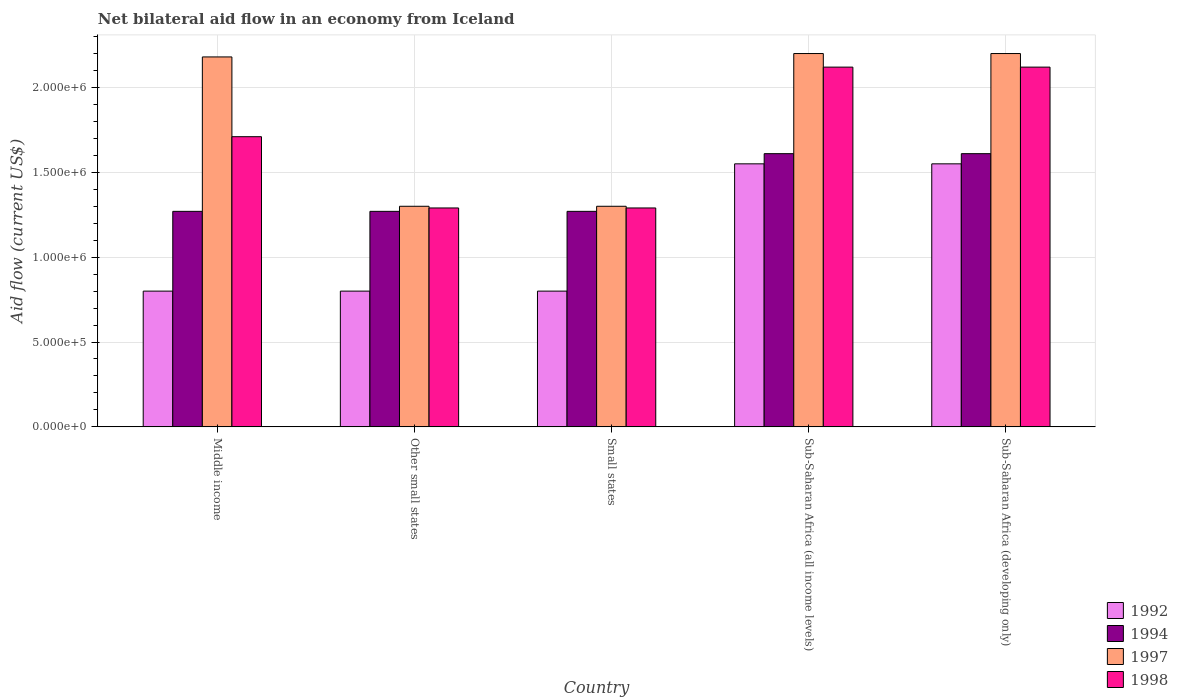How many groups of bars are there?
Your answer should be compact. 5. Are the number of bars on each tick of the X-axis equal?
Provide a short and direct response. Yes. How many bars are there on the 3rd tick from the right?
Provide a short and direct response. 4. What is the label of the 4th group of bars from the left?
Keep it short and to the point. Sub-Saharan Africa (all income levels). In how many cases, is the number of bars for a given country not equal to the number of legend labels?
Keep it short and to the point. 0. What is the net bilateral aid flow in 1998 in Sub-Saharan Africa (all income levels)?
Give a very brief answer. 2.12e+06. Across all countries, what is the maximum net bilateral aid flow in 1994?
Provide a succinct answer. 1.61e+06. Across all countries, what is the minimum net bilateral aid flow in 1992?
Your answer should be very brief. 8.00e+05. In which country was the net bilateral aid flow in 1994 maximum?
Give a very brief answer. Sub-Saharan Africa (all income levels). In which country was the net bilateral aid flow in 1998 minimum?
Offer a terse response. Other small states. What is the total net bilateral aid flow in 1998 in the graph?
Your answer should be very brief. 8.53e+06. What is the difference between the net bilateral aid flow in 1998 in Other small states and that in Sub-Saharan Africa (developing only)?
Keep it short and to the point. -8.30e+05. What is the difference between the net bilateral aid flow in 1997 in Middle income and the net bilateral aid flow in 1994 in Small states?
Offer a terse response. 9.10e+05. What is the average net bilateral aid flow in 1997 per country?
Your response must be concise. 1.84e+06. What is the difference between the net bilateral aid flow of/in 1992 and net bilateral aid flow of/in 1997 in Other small states?
Make the answer very short. -5.00e+05. What is the ratio of the net bilateral aid flow in 1992 in Middle income to that in Sub-Saharan Africa (all income levels)?
Keep it short and to the point. 0.52. Is the net bilateral aid flow in 1998 in Small states less than that in Sub-Saharan Africa (all income levels)?
Your response must be concise. Yes. Is the difference between the net bilateral aid flow in 1992 in Small states and Sub-Saharan Africa (all income levels) greater than the difference between the net bilateral aid flow in 1997 in Small states and Sub-Saharan Africa (all income levels)?
Offer a very short reply. Yes. What is the difference between the highest and the second highest net bilateral aid flow in 1998?
Give a very brief answer. 4.10e+05. In how many countries, is the net bilateral aid flow in 1992 greater than the average net bilateral aid flow in 1992 taken over all countries?
Keep it short and to the point. 2. Is it the case that in every country, the sum of the net bilateral aid flow in 1992 and net bilateral aid flow in 1998 is greater than the sum of net bilateral aid flow in 1994 and net bilateral aid flow in 1997?
Give a very brief answer. No. What does the 1st bar from the left in Sub-Saharan Africa (developing only) represents?
Offer a very short reply. 1992. What does the 4th bar from the right in Small states represents?
Make the answer very short. 1992. Is it the case that in every country, the sum of the net bilateral aid flow in 1992 and net bilateral aid flow in 1994 is greater than the net bilateral aid flow in 1997?
Provide a succinct answer. No. How many bars are there?
Make the answer very short. 20. Are the values on the major ticks of Y-axis written in scientific E-notation?
Ensure brevity in your answer.  Yes. Does the graph contain any zero values?
Make the answer very short. No. Does the graph contain grids?
Your answer should be compact. Yes. Where does the legend appear in the graph?
Keep it short and to the point. Bottom right. How many legend labels are there?
Make the answer very short. 4. How are the legend labels stacked?
Offer a terse response. Vertical. What is the title of the graph?
Offer a terse response. Net bilateral aid flow in an economy from Iceland. Does "1994" appear as one of the legend labels in the graph?
Ensure brevity in your answer.  Yes. What is the label or title of the Y-axis?
Provide a succinct answer. Aid flow (current US$). What is the Aid flow (current US$) of 1992 in Middle income?
Keep it short and to the point. 8.00e+05. What is the Aid flow (current US$) of 1994 in Middle income?
Provide a succinct answer. 1.27e+06. What is the Aid flow (current US$) of 1997 in Middle income?
Ensure brevity in your answer.  2.18e+06. What is the Aid flow (current US$) in 1998 in Middle income?
Offer a very short reply. 1.71e+06. What is the Aid flow (current US$) of 1992 in Other small states?
Keep it short and to the point. 8.00e+05. What is the Aid flow (current US$) of 1994 in Other small states?
Keep it short and to the point. 1.27e+06. What is the Aid flow (current US$) of 1997 in Other small states?
Your answer should be very brief. 1.30e+06. What is the Aid flow (current US$) in 1998 in Other small states?
Make the answer very short. 1.29e+06. What is the Aid flow (current US$) in 1994 in Small states?
Keep it short and to the point. 1.27e+06. What is the Aid flow (current US$) in 1997 in Small states?
Keep it short and to the point. 1.30e+06. What is the Aid flow (current US$) of 1998 in Small states?
Provide a succinct answer. 1.29e+06. What is the Aid flow (current US$) in 1992 in Sub-Saharan Africa (all income levels)?
Provide a short and direct response. 1.55e+06. What is the Aid flow (current US$) in 1994 in Sub-Saharan Africa (all income levels)?
Ensure brevity in your answer.  1.61e+06. What is the Aid flow (current US$) of 1997 in Sub-Saharan Africa (all income levels)?
Offer a very short reply. 2.20e+06. What is the Aid flow (current US$) of 1998 in Sub-Saharan Africa (all income levels)?
Keep it short and to the point. 2.12e+06. What is the Aid flow (current US$) in 1992 in Sub-Saharan Africa (developing only)?
Your answer should be very brief. 1.55e+06. What is the Aid flow (current US$) of 1994 in Sub-Saharan Africa (developing only)?
Keep it short and to the point. 1.61e+06. What is the Aid flow (current US$) in 1997 in Sub-Saharan Africa (developing only)?
Make the answer very short. 2.20e+06. What is the Aid flow (current US$) of 1998 in Sub-Saharan Africa (developing only)?
Your response must be concise. 2.12e+06. Across all countries, what is the maximum Aid flow (current US$) of 1992?
Your answer should be compact. 1.55e+06. Across all countries, what is the maximum Aid flow (current US$) of 1994?
Make the answer very short. 1.61e+06. Across all countries, what is the maximum Aid flow (current US$) of 1997?
Offer a terse response. 2.20e+06. Across all countries, what is the maximum Aid flow (current US$) of 1998?
Give a very brief answer. 2.12e+06. Across all countries, what is the minimum Aid flow (current US$) in 1992?
Offer a very short reply. 8.00e+05. Across all countries, what is the minimum Aid flow (current US$) of 1994?
Ensure brevity in your answer.  1.27e+06. Across all countries, what is the minimum Aid flow (current US$) in 1997?
Make the answer very short. 1.30e+06. Across all countries, what is the minimum Aid flow (current US$) in 1998?
Keep it short and to the point. 1.29e+06. What is the total Aid flow (current US$) of 1992 in the graph?
Offer a terse response. 5.50e+06. What is the total Aid flow (current US$) in 1994 in the graph?
Make the answer very short. 7.03e+06. What is the total Aid flow (current US$) in 1997 in the graph?
Offer a terse response. 9.18e+06. What is the total Aid flow (current US$) in 1998 in the graph?
Keep it short and to the point. 8.53e+06. What is the difference between the Aid flow (current US$) in 1992 in Middle income and that in Other small states?
Keep it short and to the point. 0. What is the difference between the Aid flow (current US$) of 1997 in Middle income and that in Other small states?
Offer a terse response. 8.80e+05. What is the difference between the Aid flow (current US$) in 1998 in Middle income and that in Other small states?
Give a very brief answer. 4.20e+05. What is the difference between the Aid flow (current US$) in 1997 in Middle income and that in Small states?
Offer a terse response. 8.80e+05. What is the difference between the Aid flow (current US$) in 1992 in Middle income and that in Sub-Saharan Africa (all income levels)?
Offer a terse response. -7.50e+05. What is the difference between the Aid flow (current US$) in 1994 in Middle income and that in Sub-Saharan Africa (all income levels)?
Offer a terse response. -3.40e+05. What is the difference between the Aid flow (current US$) in 1998 in Middle income and that in Sub-Saharan Africa (all income levels)?
Your answer should be very brief. -4.10e+05. What is the difference between the Aid flow (current US$) of 1992 in Middle income and that in Sub-Saharan Africa (developing only)?
Offer a very short reply. -7.50e+05. What is the difference between the Aid flow (current US$) in 1994 in Middle income and that in Sub-Saharan Africa (developing only)?
Make the answer very short. -3.40e+05. What is the difference between the Aid flow (current US$) of 1998 in Middle income and that in Sub-Saharan Africa (developing only)?
Keep it short and to the point. -4.10e+05. What is the difference between the Aid flow (current US$) of 1992 in Other small states and that in Small states?
Your answer should be very brief. 0. What is the difference between the Aid flow (current US$) in 1994 in Other small states and that in Small states?
Offer a very short reply. 0. What is the difference between the Aid flow (current US$) of 1997 in Other small states and that in Small states?
Give a very brief answer. 0. What is the difference between the Aid flow (current US$) of 1992 in Other small states and that in Sub-Saharan Africa (all income levels)?
Provide a succinct answer. -7.50e+05. What is the difference between the Aid flow (current US$) in 1994 in Other small states and that in Sub-Saharan Africa (all income levels)?
Your answer should be very brief. -3.40e+05. What is the difference between the Aid flow (current US$) of 1997 in Other small states and that in Sub-Saharan Africa (all income levels)?
Give a very brief answer. -9.00e+05. What is the difference between the Aid flow (current US$) in 1998 in Other small states and that in Sub-Saharan Africa (all income levels)?
Provide a succinct answer. -8.30e+05. What is the difference between the Aid flow (current US$) of 1992 in Other small states and that in Sub-Saharan Africa (developing only)?
Your answer should be compact. -7.50e+05. What is the difference between the Aid flow (current US$) in 1994 in Other small states and that in Sub-Saharan Africa (developing only)?
Provide a short and direct response. -3.40e+05. What is the difference between the Aid flow (current US$) of 1997 in Other small states and that in Sub-Saharan Africa (developing only)?
Make the answer very short. -9.00e+05. What is the difference between the Aid flow (current US$) in 1998 in Other small states and that in Sub-Saharan Africa (developing only)?
Ensure brevity in your answer.  -8.30e+05. What is the difference between the Aid flow (current US$) of 1992 in Small states and that in Sub-Saharan Africa (all income levels)?
Provide a succinct answer. -7.50e+05. What is the difference between the Aid flow (current US$) in 1997 in Small states and that in Sub-Saharan Africa (all income levels)?
Offer a very short reply. -9.00e+05. What is the difference between the Aid flow (current US$) of 1998 in Small states and that in Sub-Saharan Africa (all income levels)?
Your response must be concise. -8.30e+05. What is the difference between the Aid flow (current US$) of 1992 in Small states and that in Sub-Saharan Africa (developing only)?
Ensure brevity in your answer.  -7.50e+05. What is the difference between the Aid flow (current US$) of 1994 in Small states and that in Sub-Saharan Africa (developing only)?
Ensure brevity in your answer.  -3.40e+05. What is the difference between the Aid flow (current US$) in 1997 in Small states and that in Sub-Saharan Africa (developing only)?
Keep it short and to the point. -9.00e+05. What is the difference between the Aid flow (current US$) of 1998 in Small states and that in Sub-Saharan Africa (developing only)?
Your response must be concise. -8.30e+05. What is the difference between the Aid flow (current US$) of 1992 in Sub-Saharan Africa (all income levels) and that in Sub-Saharan Africa (developing only)?
Your answer should be compact. 0. What is the difference between the Aid flow (current US$) in 1997 in Sub-Saharan Africa (all income levels) and that in Sub-Saharan Africa (developing only)?
Provide a succinct answer. 0. What is the difference between the Aid flow (current US$) in 1992 in Middle income and the Aid flow (current US$) in 1994 in Other small states?
Your response must be concise. -4.70e+05. What is the difference between the Aid flow (current US$) in 1992 in Middle income and the Aid flow (current US$) in 1997 in Other small states?
Give a very brief answer. -5.00e+05. What is the difference between the Aid flow (current US$) of 1992 in Middle income and the Aid flow (current US$) of 1998 in Other small states?
Make the answer very short. -4.90e+05. What is the difference between the Aid flow (current US$) of 1997 in Middle income and the Aid flow (current US$) of 1998 in Other small states?
Your answer should be compact. 8.90e+05. What is the difference between the Aid flow (current US$) in 1992 in Middle income and the Aid flow (current US$) in 1994 in Small states?
Keep it short and to the point. -4.70e+05. What is the difference between the Aid flow (current US$) of 1992 in Middle income and the Aid flow (current US$) of 1997 in Small states?
Offer a very short reply. -5.00e+05. What is the difference between the Aid flow (current US$) of 1992 in Middle income and the Aid flow (current US$) of 1998 in Small states?
Give a very brief answer. -4.90e+05. What is the difference between the Aid flow (current US$) of 1994 in Middle income and the Aid flow (current US$) of 1997 in Small states?
Your answer should be compact. -3.00e+04. What is the difference between the Aid flow (current US$) in 1994 in Middle income and the Aid flow (current US$) in 1998 in Small states?
Provide a short and direct response. -2.00e+04. What is the difference between the Aid flow (current US$) of 1997 in Middle income and the Aid flow (current US$) of 1998 in Small states?
Offer a very short reply. 8.90e+05. What is the difference between the Aid flow (current US$) of 1992 in Middle income and the Aid flow (current US$) of 1994 in Sub-Saharan Africa (all income levels)?
Keep it short and to the point. -8.10e+05. What is the difference between the Aid flow (current US$) in 1992 in Middle income and the Aid flow (current US$) in 1997 in Sub-Saharan Africa (all income levels)?
Provide a short and direct response. -1.40e+06. What is the difference between the Aid flow (current US$) in 1992 in Middle income and the Aid flow (current US$) in 1998 in Sub-Saharan Africa (all income levels)?
Make the answer very short. -1.32e+06. What is the difference between the Aid flow (current US$) in 1994 in Middle income and the Aid flow (current US$) in 1997 in Sub-Saharan Africa (all income levels)?
Offer a very short reply. -9.30e+05. What is the difference between the Aid flow (current US$) in 1994 in Middle income and the Aid flow (current US$) in 1998 in Sub-Saharan Africa (all income levels)?
Provide a short and direct response. -8.50e+05. What is the difference between the Aid flow (current US$) in 1997 in Middle income and the Aid flow (current US$) in 1998 in Sub-Saharan Africa (all income levels)?
Your response must be concise. 6.00e+04. What is the difference between the Aid flow (current US$) of 1992 in Middle income and the Aid flow (current US$) of 1994 in Sub-Saharan Africa (developing only)?
Make the answer very short. -8.10e+05. What is the difference between the Aid flow (current US$) of 1992 in Middle income and the Aid flow (current US$) of 1997 in Sub-Saharan Africa (developing only)?
Provide a succinct answer. -1.40e+06. What is the difference between the Aid flow (current US$) in 1992 in Middle income and the Aid flow (current US$) in 1998 in Sub-Saharan Africa (developing only)?
Your answer should be compact. -1.32e+06. What is the difference between the Aid flow (current US$) in 1994 in Middle income and the Aid flow (current US$) in 1997 in Sub-Saharan Africa (developing only)?
Make the answer very short. -9.30e+05. What is the difference between the Aid flow (current US$) in 1994 in Middle income and the Aid flow (current US$) in 1998 in Sub-Saharan Africa (developing only)?
Ensure brevity in your answer.  -8.50e+05. What is the difference between the Aid flow (current US$) of 1992 in Other small states and the Aid flow (current US$) of 1994 in Small states?
Your answer should be very brief. -4.70e+05. What is the difference between the Aid flow (current US$) in 1992 in Other small states and the Aid flow (current US$) in 1997 in Small states?
Your response must be concise. -5.00e+05. What is the difference between the Aid flow (current US$) of 1992 in Other small states and the Aid flow (current US$) of 1998 in Small states?
Make the answer very short. -4.90e+05. What is the difference between the Aid flow (current US$) in 1994 in Other small states and the Aid flow (current US$) in 1997 in Small states?
Your answer should be compact. -3.00e+04. What is the difference between the Aid flow (current US$) in 1994 in Other small states and the Aid flow (current US$) in 1998 in Small states?
Provide a succinct answer. -2.00e+04. What is the difference between the Aid flow (current US$) of 1997 in Other small states and the Aid flow (current US$) of 1998 in Small states?
Your answer should be very brief. 10000. What is the difference between the Aid flow (current US$) in 1992 in Other small states and the Aid flow (current US$) in 1994 in Sub-Saharan Africa (all income levels)?
Your answer should be very brief. -8.10e+05. What is the difference between the Aid flow (current US$) in 1992 in Other small states and the Aid flow (current US$) in 1997 in Sub-Saharan Africa (all income levels)?
Make the answer very short. -1.40e+06. What is the difference between the Aid flow (current US$) in 1992 in Other small states and the Aid flow (current US$) in 1998 in Sub-Saharan Africa (all income levels)?
Provide a succinct answer. -1.32e+06. What is the difference between the Aid flow (current US$) in 1994 in Other small states and the Aid flow (current US$) in 1997 in Sub-Saharan Africa (all income levels)?
Your answer should be very brief. -9.30e+05. What is the difference between the Aid flow (current US$) of 1994 in Other small states and the Aid flow (current US$) of 1998 in Sub-Saharan Africa (all income levels)?
Provide a short and direct response. -8.50e+05. What is the difference between the Aid flow (current US$) in 1997 in Other small states and the Aid flow (current US$) in 1998 in Sub-Saharan Africa (all income levels)?
Provide a short and direct response. -8.20e+05. What is the difference between the Aid flow (current US$) in 1992 in Other small states and the Aid flow (current US$) in 1994 in Sub-Saharan Africa (developing only)?
Provide a succinct answer. -8.10e+05. What is the difference between the Aid flow (current US$) in 1992 in Other small states and the Aid flow (current US$) in 1997 in Sub-Saharan Africa (developing only)?
Your answer should be compact. -1.40e+06. What is the difference between the Aid flow (current US$) in 1992 in Other small states and the Aid flow (current US$) in 1998 in Sub-Saharan Africa (developing only)?
Make the answer very short. -1.32e+06. What is the difference between the Aid flow (current US$) in 1994 in Other small states and the Aid flow (current US$) in 1997 in Sub-Saharan Africa (developing only)?
Ensure brevity in your answer.  -9.30e+05. What is the difference between the Aid flow (current US$) of 1994 in Other small states and the Aid flow (current US$) of 1998 in Sub-Saharan Africa (developing only)?
Offer a very short reply. -8.50e+05. What is the difference between the Aid flow (current US$) of 1997 in Other small states and the Aid flow (current US$) of 1998 in Sub-Saharan Africa (developing only)?
Your answer should be very brief. -8.20e+05. What is the difference between the Aid flow (current US$) in 1992 in Small states and the Aid flow (current US$) in 1994 in Sub-Saharan Africa (all income levels)?
Make the answer very short. -8.10e+05. What is the difference between the Aid flow (current US$) of 1992 in Small states and the Aid flow (current US$) of 1997 in Sub-Saharan Africa (all income levels)?
Offer a very short reply. -1.40e+06. What is the difference between the Aid flow (current US$) of 1992 in Small states and the Aid flow (current US$) of 1998 in Sub-Saharan Africa (all income levels)?
Your answer should be very brief. -1.32e+06. What is the difference between the Aid flow (current US$) in 1994 in Small states and the Aid flow (current US$) in 1997 in Sub-Saharan Africa (all income levels)?
Provide a succinct answer. -9.30e+05. What is the difference between the Aid flow (current US$) in 1994 in Small states and the Aid flow (current US$) in 1998 in Sub-Saharan Africa (all income levels)?
Your answer should be very brief. -8.50e+05. What is the difference between the Aid flow (current US$) of 1997 in Small states and the Aid flow (current US$) of 1998 in Sub-Saharan Africa (all income levels)?
Make the answer very short. -8.20e+05. What is the difference between the Aid flow (current US$) of 1992 in Small states and the Aid flow (current US$) of 1994 in Sub-Saharan Africa (developing only)?
Make the answer very short. -8.10e+05. What is the difference between the Aid flow (current US$) of 1992 in Small states and the Aid flow (current US$) of 1997 in Sub-Saharan Africa (developing only)?
Give a very brief answer. -1.40e+06. What is the difference between the Aid flow (current US$) of 1992 in Small states and the Aid flow (current US$) of 1998 in Sub-Saharan Africa (developing only)?
Make the answer very short. -1.32e+06. What is the difference between the Aid flow (current US$) in 1994 in Small states and the Aid flow (current US$) in 1997 in Sub-Saharan Africa (developing only)?
Make the answer very short. -9.30e+05. What is the difference between the Aid flow (current US$) of 1994 in Small states and the Aid flow (current US$) of 1998 in Sub-Saharan Africa (developing only)?
Ensure brevity in your answer.  -8.50e+05. What is the difference between the Aid flow (current US$) of 1997 in Small states and the Aid flow (current US$) of 1998 in Sub-Saharan Africa (developing only)?
Provide a short and direct response. -8.20e+05. What is the difference between the Aid flow (current US$) in 1992 in Sub-Saharan Africa (all income levels) and the Aid flow (current US$) in 1994 in Sub-Saharan Africa (developing only)?
Your answer should be very brief. -6.00e+04. What is the difference between the Aid flow (current US$) in 1992 in Sub-Saharan Africa (all income levels) and the Aid flow (current US$) in 1997 in Sub-Saharan Africa (developing only)?
Give a very brief answer. -6.50e+05. What is the difference between the Aid flow (current US$) of 1992 in Sub-Saharan Africa (all income levels) and the Aid flow (current US$) of 1998 in Sub-Saharan Africa (developing only)?
Provide a succinct answer. -5.70e+05. What is the difference between the Aid flow (current US$) in 1994 in Sub-Saharan Africa (all income levels) and the Aid flow (current US$) in 1997 in Sub-Saharan Africa (developing only)?
Provide a succinct answer. -5.90e+05. What is the difference between the Aid flow (current US$) in 1994 in Sub-Saharan Africa (all income levels) and the Aid flow (current US$) in 1998 in Sub-Saharan Africa (developing only)?
Your answer should be very brief. -5.10e+05. What is the difference between the Aid flow (current US$) in 1997 in Sub-Saharan Africa (all income levels) and the Aid flow (current US$) in 1998 in Sub-Saharan Africa (developing only)?
Your response must be concise. 8.00e+04. What is the average Aid flow (current US$) in 1992 per country?
Your answer should be compact. 1.10e+06. What is the average Aid flow (current US$) in 1994 per country?
Your response must be concise. 1.41e+06. What is the average Aid flow (current US$) in 1997 per country?
Provide a succinct answer. 1.84e+06. What is the average Aid flow (current US$) in 1998 per country?
Provide a short and direct response. 1.71e+06. What is the difference between the Aid flow (current US$) of 1992 and Aid flow (current US$) of 1994 in Middle income?
Give a very brief answer. -4.70e+05. What is the difference between the Aid flow (current US$) of 1992 and Aid flow (current US$) of 1997 in Middle income?
Ensure brevity in your answer.  -1.38e+06. What is the difference between the Aid flow (current US$) of 1992 and Aid flow (current US$) of 1998 in Middle income?
Offer a very short reply. -9.10e+05. What is the difference between the Aid flow (current US$) in 1994 and Aid flow (current US$) in 1997 in Middle income?
Make the answer very short. -9.10e+05. What is the difference between the Aid flow (current US$) of 1994 and Aid flow (current US$) of 1998 in Middle income?
Your answer should be very brief. -4.40e+05. What is the difference between the Aid flow (current US$) in 1992 and Aid flow (current US$) in 1994 in Other small states?
Ensure brevity in your answer.  -4.70e+05. What is the difference between the Aid flow (current US$) of 1992 and Aid flow (current US$) of 1997 in Other small states?
Your response must be concise. -5.00e+05. What is the difference between the Aid flow (current US$) in 1992 and Aid flow (current US$) in 1998 in Other small states?
Your answer should be very brief. -4.90e+05. What is the difference between the Aid flow (current US$) of 1994 and Aid flow (current US$) of 1998 in Other small states?
Offer a very short reply. -2.00e+04. What is the difference between the Aid flow (current US$) in 1992 and Aid flow (current US$) in 1994 in Small states?
Offer a very short reply. -4.70e+05. What is the difference between the Aid flow (current US$) of 1992 and Aid flow (current US$) of 1997 in Small states?
Provide a succinct answer. -5.00e+05. What is the difference between the Aid flow (current US$) of 1992 and Aid flow (current US$) of 1998 in Small states?
Your response must be concise. -4.90e+05. What is the difference between the Aid flow (current US$) in 1994 and Aid flow (current US$) in 1997 in Small states?
Provide a succinct answer. -3.00e+04. What is the difference between the Aid flow (current US$) of 1994 and Aid flow (current US$) of 1998 in Small states?
Your response must be concise. -2.00e+04. What is the difference between the Aid flow (current US$) in 1997 and Aid flow (current US$) in 1998 in Small states?
Provide a short and direct response. 10000. What is the difference between the Aid flow (current US$) of 1992 and Aid flow (current US$) of 1994 in Sub-Saharan Africa (all income levels)?
Make the answer very short. -6.00e+04. What is the difference between the Aid flow (current US$) in 1992 and Aid flow (current US$) in 1997 in Sub-Saharan Africa (all income levels)?
Provide a succinct answer. -6.50e+05. What is the difference between the Aid flow (current US$) of 1992 and Aid flow (current US$) of 1998 in Sub-Saharan Africa (all income levels)?
Ensure brevity in your answer.  -5.70e+05. What is the difference between the Aid flow (current US$) in 1994 and Aid flow (current US$) in 1997 in Sub-Saharan Africa (all income levels)?
Ensure brevity in your answer.  -5.90e+05. What is the difference between the Aid flow (current US$) in 1994 and Aid flow (current US$) in 1998 in Sub-Saharan Africa (all income levels)?
Ensure brevity in your answer.  -5.10e+05. What is the difference between the Aid flow (current US$) in 1992 and Aid flow (current US$) in 1994 in Sub-Saharan Africa (developing only)?
Provide a short and direct response. -6.00e+04. What is the difference between the Aid flow (current US$) of 1992 and Aid flow (current US$) of 1997 in Sub-Saharan Africa (developing only)?
Provide a short and direct response. -6.50e+05. What is the difference between the Aid flow (current US$) in 1992 and Aid flow (current US$) in 1998 in Sub-Saharan Africa (developing only)?
Provide a short and direct response. -5.70e+05. What is the difference between the Aid flow (current US$) of 1994 and Aid flow (current US$) of 1997 in Sub-Saharan Africa (developing only)?
Provide a succinct answer. -5.90e+05. What is the difference between the Aid flow (current US$) in 1994 and Aid flow (current US$) in 1998 in Sub-Saharan Africa (developing only)?
Your response must be concise. -5.10e+05. What is the ratio of the Aid flow (current US$) of 1994 in Middle income to that in Other small states?
Offer a terse response. 1. What is the ratio of the Aid flow (current US$) in 1997 in Middle income to that in Other small states?
Keep it short and to the point. 1.68. What is the ratio of the Aid flow (current US$) of 1998 in Middle income to that in Other small states?
Give a very brief answer. 1.33. What is the ratio of the Aid flow (current US$) in 1997 in Middle income to that in Small states?
Keep it short and to the point. 1.68. What is the ratio of the Aid flow (current US$) of 1998 in Middle income to that in Small states?
Keep it short and to the point. 1.33. What is the ratio of the Aid flow (current US$) of 1992 in Middle income to that in Sub-Saharan Africa (all income levels)?
Make the answer very short. 0.52. What is the ratio of the Aid flow (current US$) of 1994 in Middle income to that in Sub-Saharan Africa (all income levels)?
Your answer should be very brief. 0.79. What is the ratio of the Aid flow (current US$) of 1997 in Middle income to that in Sub-Saharan Africa (all income levels)?
Make the answer very short. 0.99. What is the ratio of the Aid flow (current US$) in 1998 in Middle income to that in Sub-Saharan Africa (all income levels)?
Keep it short and to the point. 0.81. What is the ratio of the Aid flow (current US$) in 1992 in Middle income to that in Sub-Saharan Africa (developing only)?
Your answer should be very brief. 0.52. What is the ratio of the Aid flow (current US$) of 1994 in Middle income to that in Sub-Saharan Africa (developing only)?
Keep it short and to the point. 0.79. What is the ratio of the Aid flow (current US$) in 1997 in Middle income to that in Sub-Saharan Africa (developing only)?
Keep it short and to the point. 0.99. What is the ratio of the Aid flow (current US$) of 1998 in Middle income to that in Sub-Saharan Africa (developing only)?
Your response must be concise. 0.81. What is the ratio of the Aid flow (current US$) of 1994 in Other small states to that in Small states?
Ensure brevity in your answer.  1. What is the ratio of the Aid flow (current US$) in 1997 in Other small states to that in Small states?
Your answer should be compact. 1. What is the ratio of the Aid flow (current US$) in 1998 in Other small states to that in Small states?
Offer a terse response. 1. What is the ratio of the Aid flow (current US$) in 1992 in Other small states to that in Sub-Saharan Africa (all income levels)?
Give a very brief answer. 0.52. What is the ratio of the Aid flow (current US$) in 1994 in Other small states to that in Sub-Saharan Africa (all income levels)?
Offer a very short reply. 0.79. What is the ratio of the Aid flow (current US$) of 1997 in Other small states to that in Sub-Saharan Africa (all income levels)?
Ensure brevity in your answer.  0.59. What is the ratio of the Aid flow (current US$) in 1998 in Other small states to that in Sub-Saharan Africa (all income levels)?
Your answer should be compact. 0.61. What is the ratio of the Aid flow (current US$) of 1992 in Other small states to that in Sub-Saharan Africa (developing only)?
Ensure brevity in your answer.  0.52. What is the ratio of the Aid flow (current US$) in 1994 in Other small states to that in Sub-Saharan Africa (developing only)?
Keep it short and to the point. 0.79. What is the ratio of the Aid flow (current US$) in 1997 in Other small states to that in Sub-Saharan Africa (developing only)?
Keep it short and to the point. 0.59. What is the ratio of the Aid flow (current US$) of 1998 in Other small states to that in Sub-Saharan Africa (developing only)?
Provide a succinct answer. 0.61. What is the ratio of the Aid flow (current US$) of 1992 in Small states to that in Sub-Saharan Africa (all income levels)?
Offer a terse response. 0.52. What is the ratio of the Aid flow (current US$) of 1994 in Small states to that in Sub-Saharan Africa (all income levels)?
Provide a succinct answer. 0.79. What is the ratio of the Aid flow (current US$) in 1997 in Small states to that in Sub-Saharan Africa (all income levels)?
Keep it short and to the point. 0.59. What is the ratio of the Aid flow (current US$) of 1998 in Small states to that in Sub-Saharan Africa (all income levels)?
Make the answer very short. 0.61. What is the ratio of the Aid flow (current US$) in 1992 in Small states to that in Sub-Saharan Africa (developing only)?
Give a very brief answer. 0.52. What is the ratio of the Aid flow (current US$) of 1994 in Small states to that in Sub-Saharan Africa (developing only)?
Provide a succinct answer. 0.79. What is the ratio of the Aid flow (current US$) in 1997 in Small states to that in Sub-Saharan Africa (developing only)?
Provide a short and direct response. 0.59. What is the ratio of the Aid flow (current US$) in 1998 in Small states to that in Sub-Saharan Africa (developing only)?
Your answer should be compact. 0.61. What is the ratio of the Aid flow (current US$) of 1992 in Sub-Saharan Africa (all income levels) to that in Sub-Saharan Africa (developing only)?
Give a very brief answer. 1. What is the ratio of the Aid flow (current US$) of 1994 in Sub-Saharan Africa (all income levels) to that in Sub-Saharan Africa (developing only)?
Make the answer very short. 1. What is the ratio of the Aid flow (current US$) of 1998 in Sub-Saharan Africa (all income levels) to that in Sub-Saharan Africa (developing only)?
Your answer should be very brief. 1. What is the difference between the highest and the second highest Aid flow (current US$) in 1992?
Offer a terse response. 0. What is the difference between the highest and the second highest Aid flow (current US$) of 1997?
Give a very brief answer. 0. What is the difference between the highest and the lowest Aid flow (current US$) in 1992?
Provide a short and direct response. 7.50e+05. What is the difference between the highest and the lowest Aid flow (current US$) in 1994?
Your answer should be compact. 3.40e+05. What is the difference between the highest and the lowest Aid flow (current US$) of 1997?
Offer a terse response. 9.00e+05. What is the difference between the highest and the lowest Aid flow (current US$) in 1998?
Keep it short and to the point. 8.30e+05. 